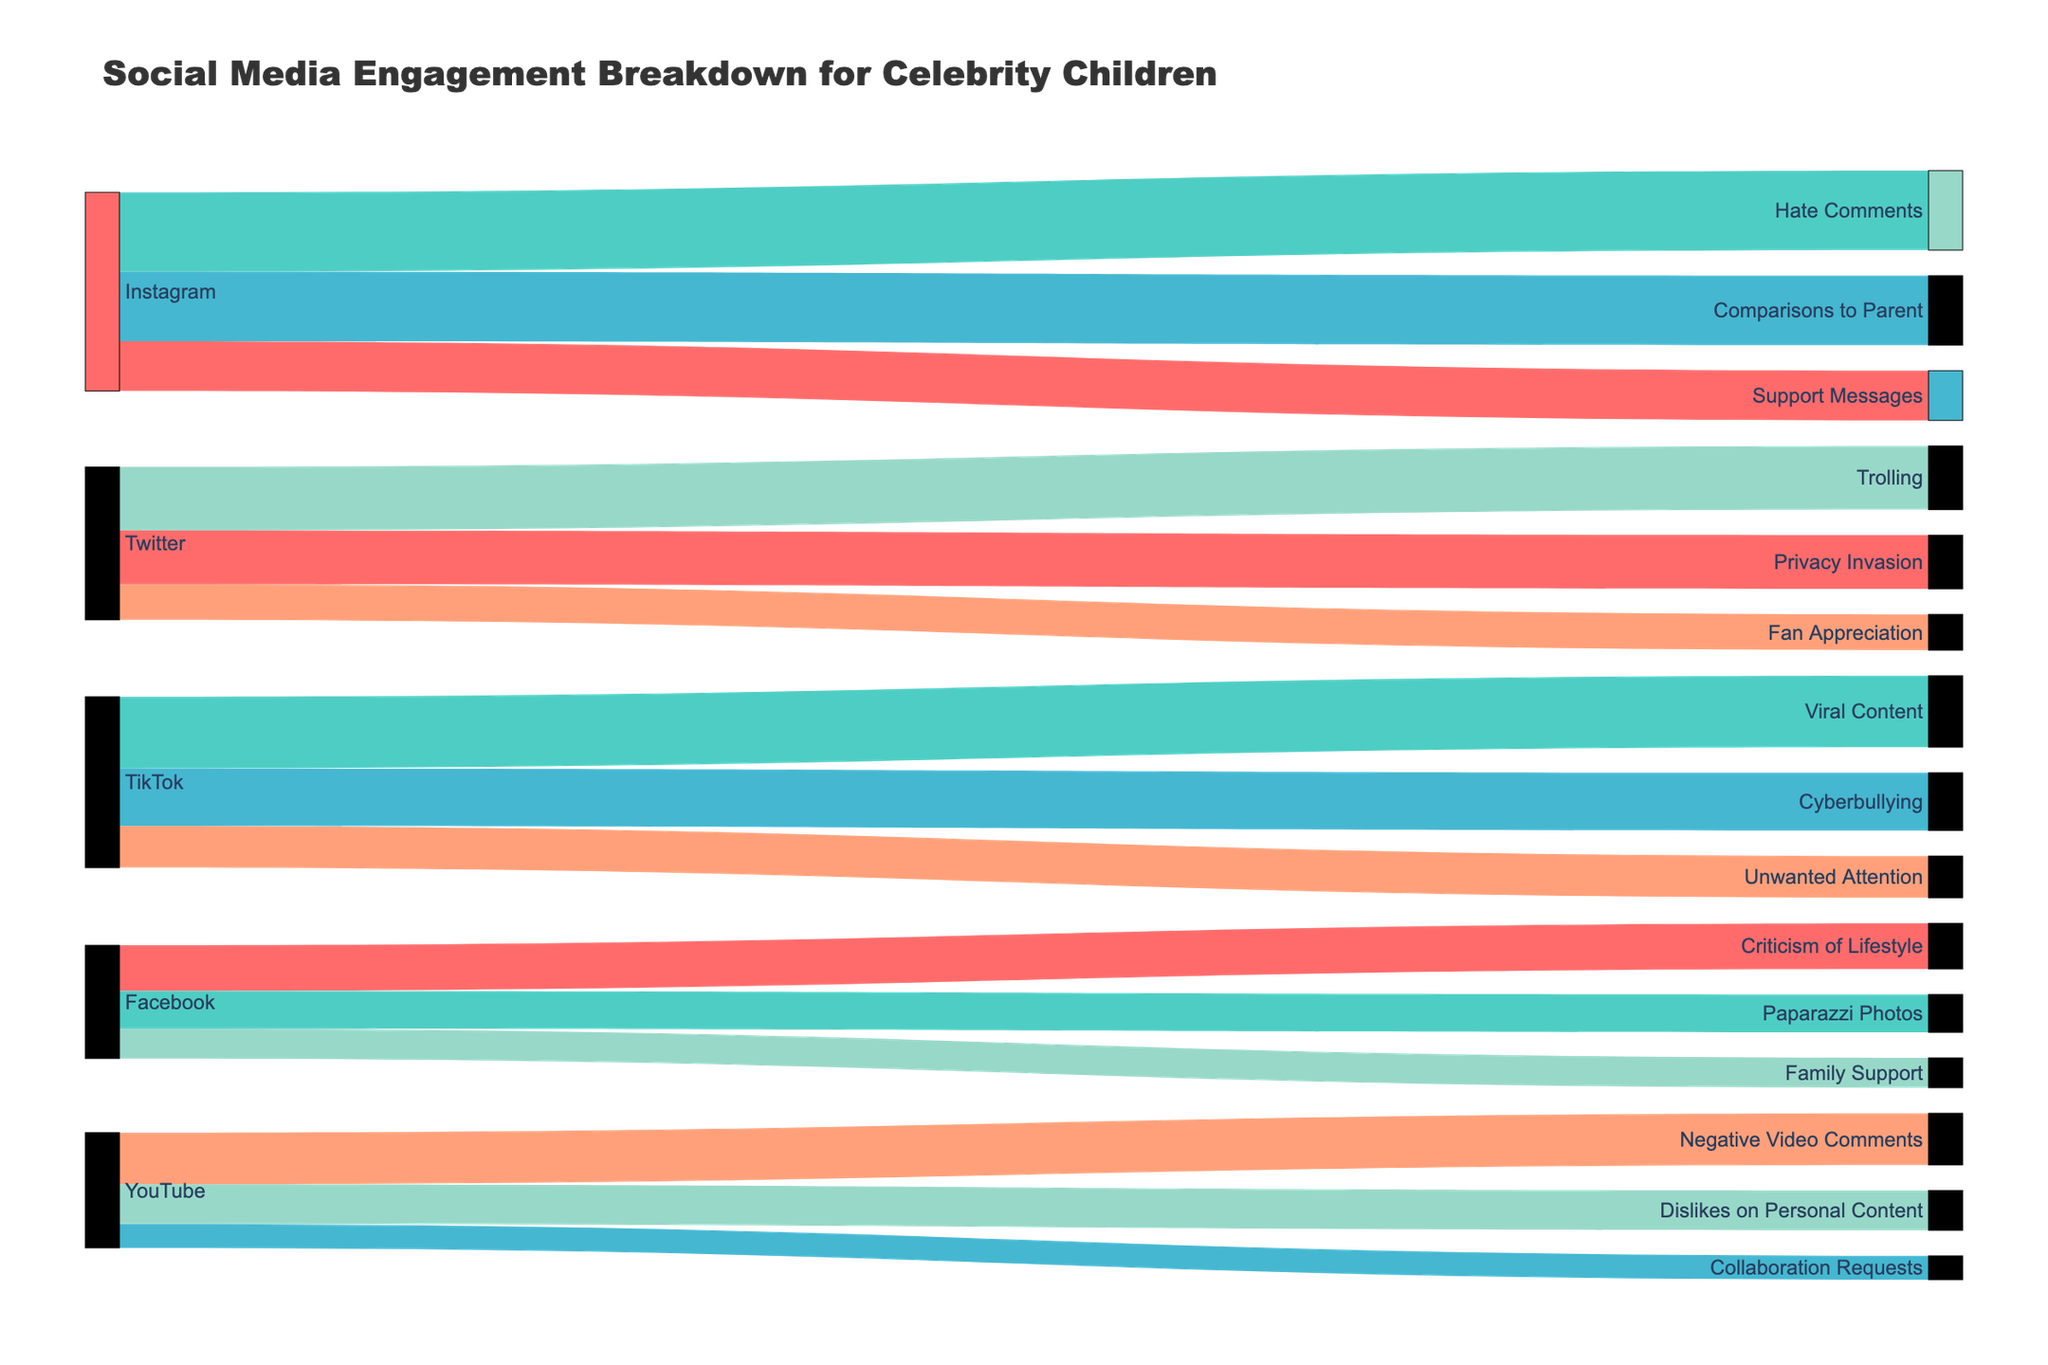Which social media platform has the highest number of negative interactions? To find this out, sum the values of all negative interactions for each platform. The negative interactions on Instagram total 7500 (4000+3500), Twitter 5900 (3200+2700), TikTok 5000 (2900+2100), Facebook 4200 (2300+1900), and YouTube 4600 (2600+2000). Instagram has the highest number of negative interactions.
Answer: Instagram What is the total number of positive interactions on all platforms? Add up the values of all positive interactions across the platforms: Instagram 2500, Twitter 1800, TikTok 3600, Facebook 1500, and YouTube 1200. The total is 2500+1800+3600+1500+1200 = 10600.
Answer: 10600 How many more hate comments on Instagram compared to cyberbullying on TikTok? Hate comments on Instagram are 4000, and cyberbullying on TikTok is 2900. Subtract to find the difference: 4000 - 2900 = 1100.
Answer: 1100 Among the positive interactions, which type has the highest value, and on which platform does it occur? Compare the values of all positive interactions: Instagram (Support Messages 2500), Twitter (Fan Appreciation 1800), TikTok (Viral Content 3600), Facebook (Family Support 1500), YouTube (Collaboration Requests 1200). The highest value is 3600 for Viral Content on TikTok.
Answer: Viral Content, TikTok How many platforms have more negative than positive interactions? Calculate the sum of negative and positive interactions for each platform: Instagram (Negative 7500, Positive 2500), Twitter (Negative 5900, Positive 1800), TikTok (Negative 5000, Positive 3600), Facebook (Negative 4200, Positive 1500), YouTube (Negative 4600, Positive 1200). Instagram, Twitter, Facebook, and YouTube have more negative than positive interactions. That's 4 platforms.
Answer: 4 What is the total number of interactions (both positive and negative) on Twitter? Sum the values of all interactions on Twitter: Positive 1800, Negative 3200 and 2700. The total is 1800+3200+2700 = 7700.
Answer: 7700 What is the difference between the total interactions on Instagram and TikTok? Sum the values of all interactions on Instagram and TikTok. Instagram: 2500 (Positive) + 4000 (Hate Comments) + 3500 (Comparisons to Parent) = 10000. TikTok: 3600 (Positive) + 2900 (Cyberbullying) + 2100 (Unwanted Attention) = 8600. The difference is 10000 - 8600 = 1400.
Answer: 1400 Which interaction type on YouTube has the lowest frequency? Compare the values for different interaction types on YouTube: Collaboration Requests 1200, Negative Video Comments 2600, Dislikes on Personal Content 2000. The lowest value is 1200 for Collaboration Requests.
Answer: Collaboration Requests 